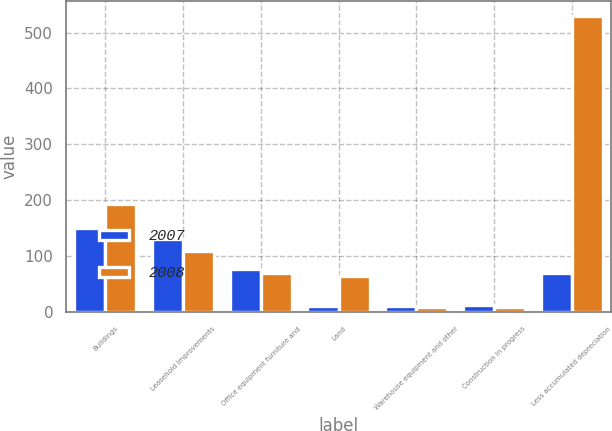<chart> <loc_0><loc_0><loc_500><loc_500><stacked_bar_chart><ecel><fcel>Buildings<fcel>Leasehold improvements<fcel>Office equipment furniture and<fcel>Land<fcel>Warehouse equipment and other<fcel>Construction in progress<fcel>Less accumulated depreciation<nl><fcel>2007<fcel>151<fcel>131<fcel>77<fcel>11<fcel>11<fcel>14<fcel>70<nl><fcel>2008<fcel>194<fcel>110<fcel>70<fcel>65<fcel>10<fcel>10<fcel>530<nl></chart> 